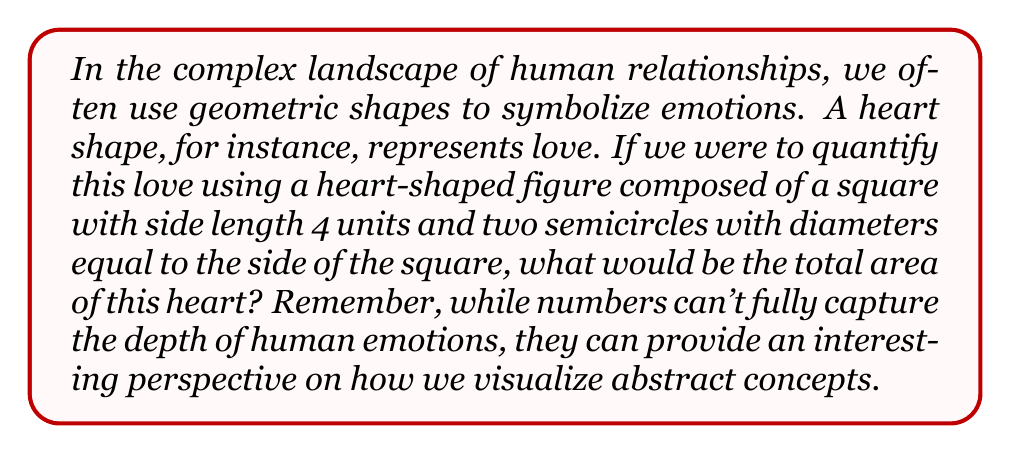Could you help me with this problem? Let's approach this step-by-step, keeping in mind that while we're using mathematical concepts, they're merely a simplified representation of complex human emotions:

1) First, we need to calculate the area of the square:
   $$ A_{square} = s^2 = 4^2 = 16 \text{ square units} $$

2) Next, we'll calculate the area of one semicircle:
   The radius of each semicircle is half the side length of the square:
   $$ r = \frac{4}{2} = 2 \text{ units} $$
   The area of a full circle is $\pi r^2$, so a semicircle is half of that:
   $$ A_{semicircle} = \frac{1}{2} \pi r^2 = \frac{1}{2} \pi (2^2) = 2\pi \text{ square units} $$

3) There are two semicircles, so we double this:
   $$ A_{two semicircles} = 2(2\pi) = 4\pi \text{ square units} $$

4) The total area of the heart is the sum of the square and the two semicircles:
   $$ A_{total} = A_{square} + A_{two semicircles} = 16 + 4\pi \text{ square units} $$

While this calculation gives us a numerical value, it's important to remember that love and relationships are far more nuanced and complex than any geometric shape or mathematical formula can fully capture.
Answer: $16 + 4\pi$ square units 